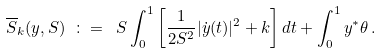Convert formula to latex. <formula><loc_0><loc_0><loc_500><loc_500>\overline { S } _ { k } ( y , S ) \ \colon = \ S \int _ { 0 } ^ { 1 } \left [ \frac { 1 } { 2 S ^ { 2 } } | \dot { y } ( t ) | ^ { 2 } + k \right ] d t + \int _ { 0 } ^ { 1 } y ^ { * } \theta \, .</formula> 